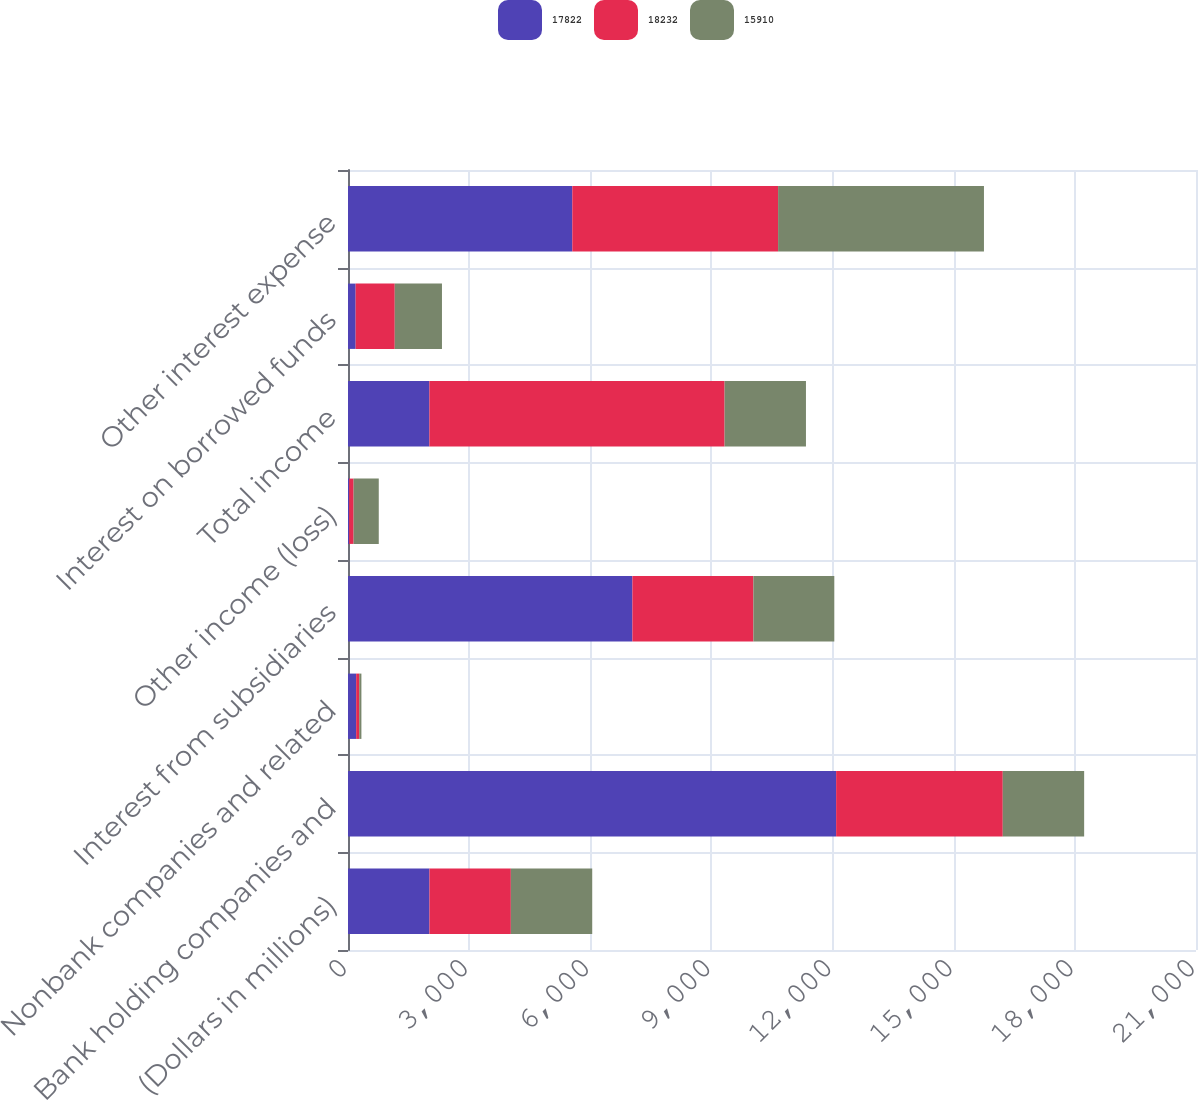Convert chart. <chart><loc_0><loc_0><loc_500><loc_500><stacked_bar_chart><ecel><fcel>(Dollars in millions)<fcel>Bank holding companies and<fcel>Nonbank companies and related<fcel>Interest from subsidiaries<fcel>Other income (loss)<fcel>Total income<fcel>Interest on borrowed funds<fcel>Other interest expense<nl><fcel>17822<fcel>2017<fcel>12088<fcel>202<fcel>7043<fcel>28<fcel>2015<fcel>189<fcel>5555<nl><fcel>18232<fcel>2016<fcel>4127<fcel>77<fcel>2996<fcel>111<fcel>7311<fcel>969<fcel>5096<nl><fcel>15910<fcel>2015<fcel>2015<fcel>53<fcel>2004<fcel>623<fcel>2015<fcel>1169<fcel>5098<nl></chart> 